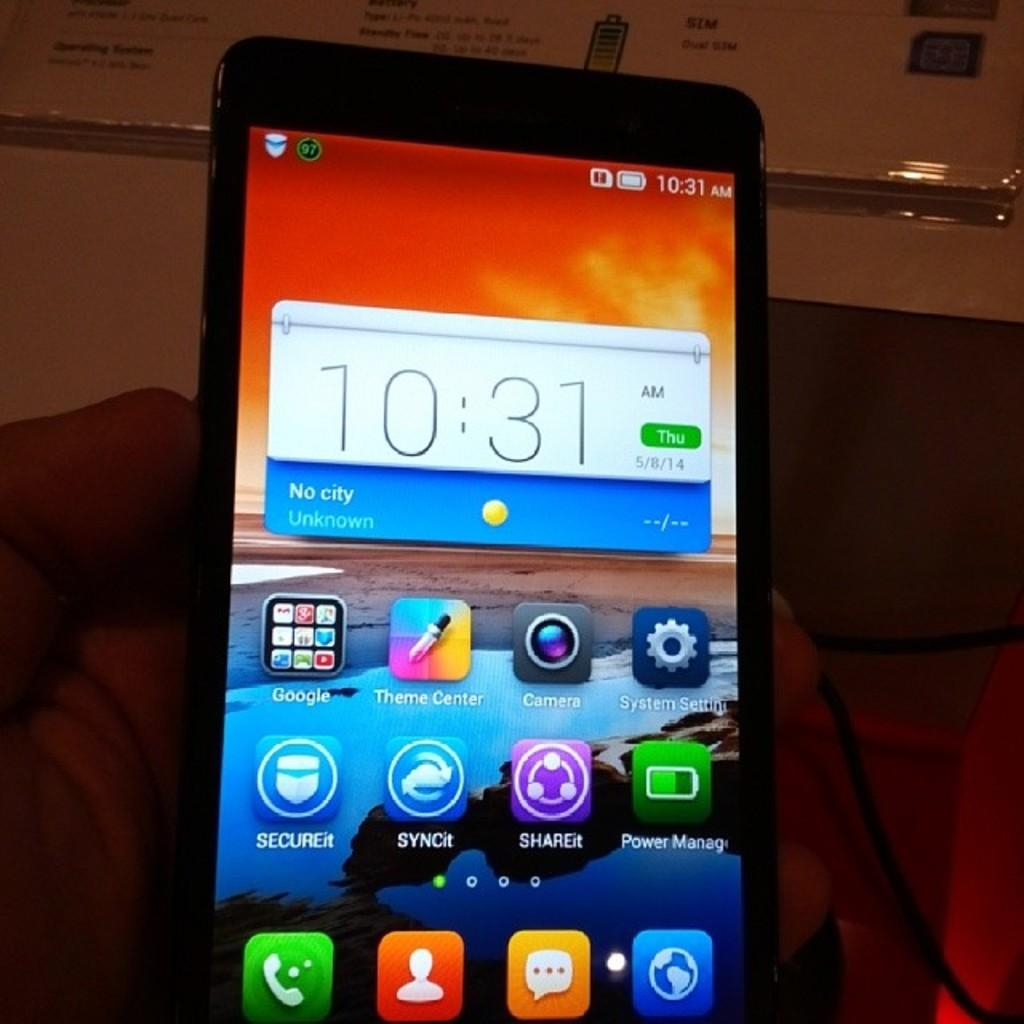<image>
Render a clear and concise summary of the photo. The time displayed on the cell phone is 10:31 AM. 